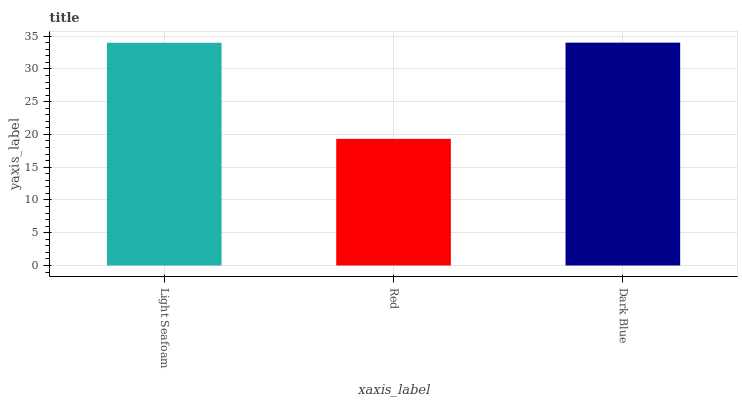Is Red the minimum?
Answer yes or no. Yes. Is Dark Blue the maximum?
Answer yes or no. Yes. Is Dark Blue the minimum?
Answer yes or no. No. Is Red the maximum?
Answer yes or no. No. Is Dark Blue greater than Red?
Answer yes or no. Yes. Is Red less than Dark Blue?
Answer yes or no. Yes. Is Red greater than Dark Blue?
Answer yes or no. No. Is Dark Blue less than Red?
Answer yes or no. No. Is Light Seafoam the high median?
Answer yes or no. Yes. Is Light Seafoam the low median?
Answer yes or no. Yes. Is Dark Blue the high median?
Answer yes or no. No. Is Red the low median?
Answer yes or no. No. 